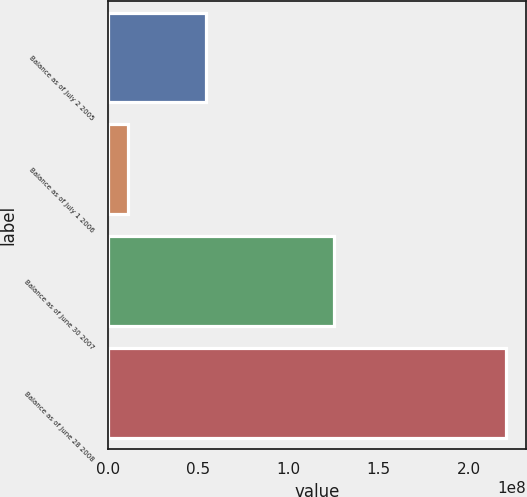Convert chart. <chart><loc_0><loc_0><loc_500><loc_500><bar_chart><fcel>Balance as of July 2 2005<fcel>Balance as of July 1 2006<fcel>Balance as of June 30 2007<fcel>Balance as of June 28 2008<nl><fcel>5.4286e+07<fcel>1.1106e+07<fcel>1.25265e+08<fcel>2.20913e+08<nl></chart> 